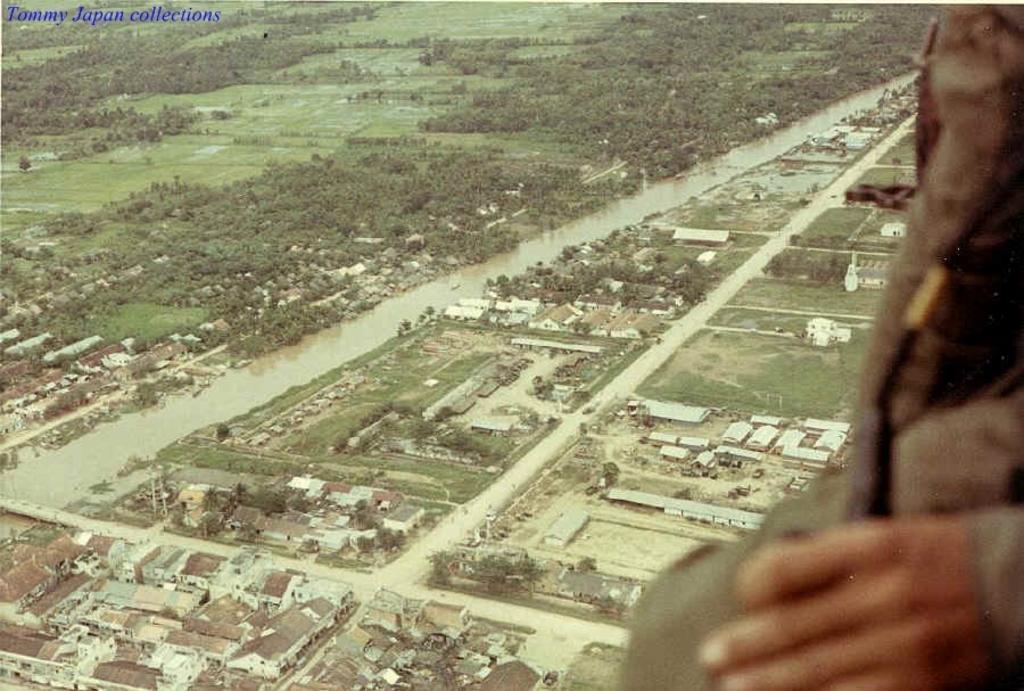In one or two sentences, can you explain what this image depicts? In this image I can see number of buildings, trees and a river. I can also see a hand of a person. 